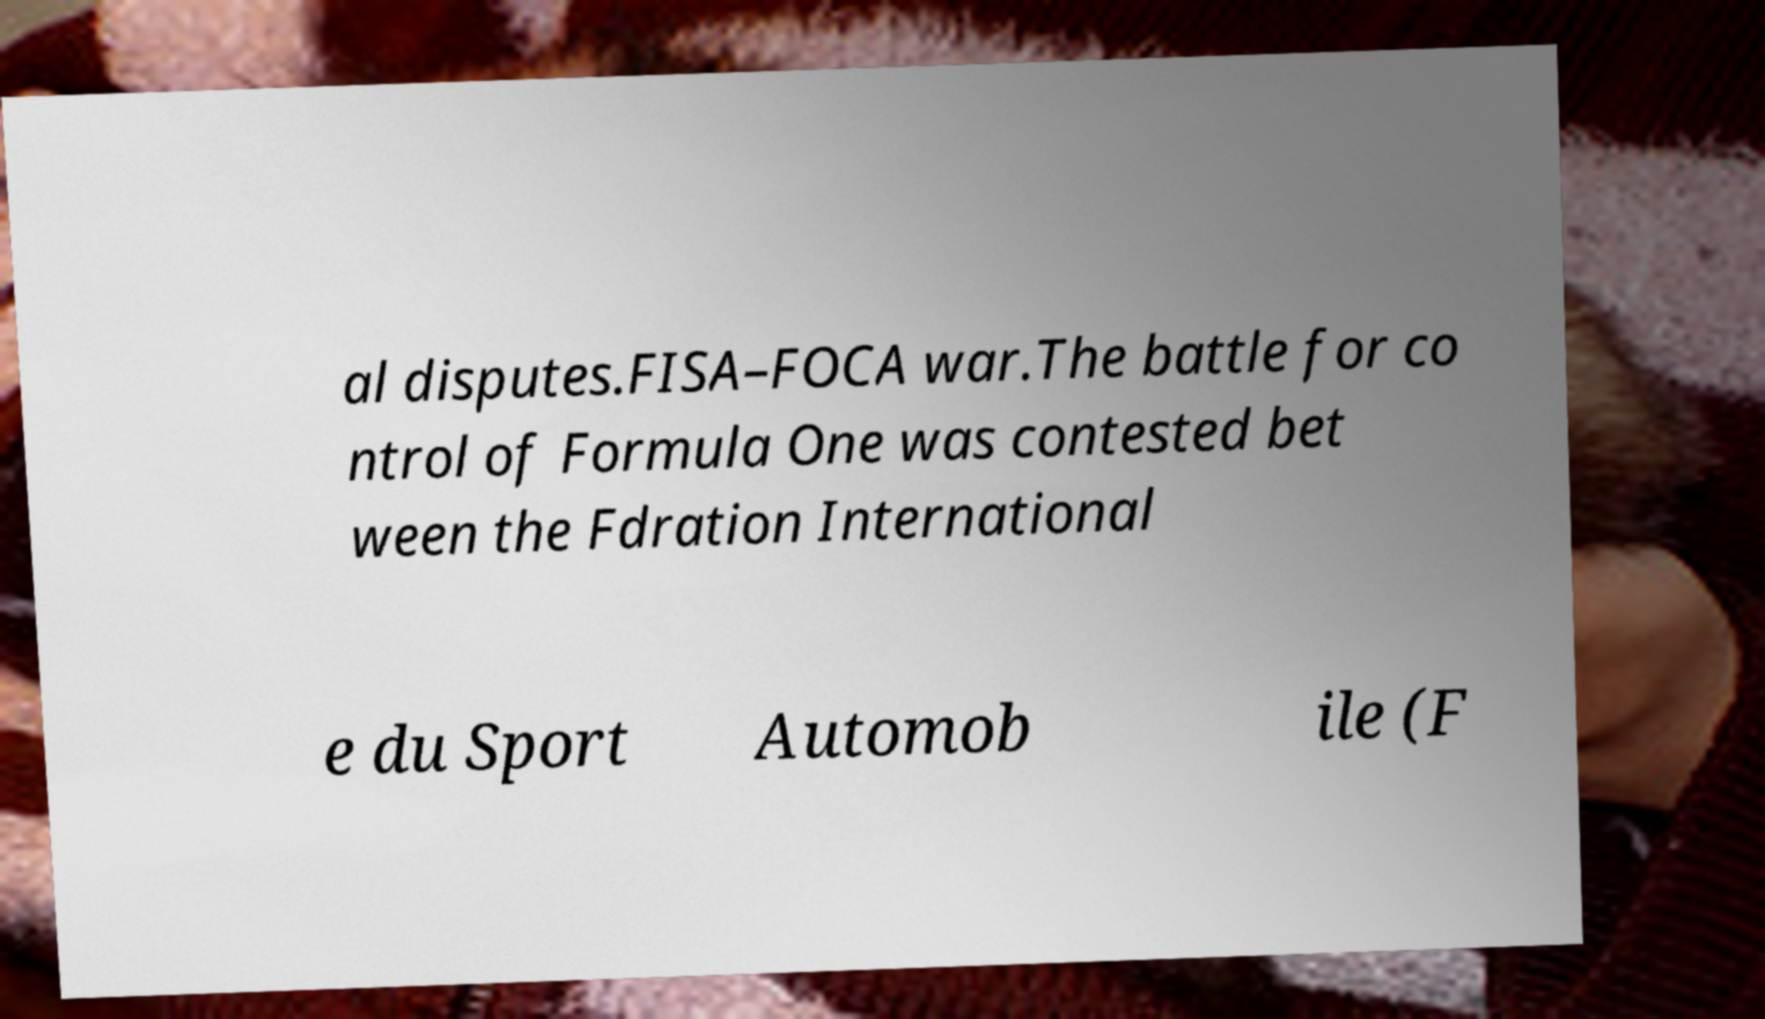Can you read and provide the text displayed in the image?This photo seems to have some interesting text. Can you extract and type it out for me? al disputes.FISA–FOCA war.The battle for co ntrol of Formula One was contested bet ween the Fdration International e du Sport Automob ile (F 